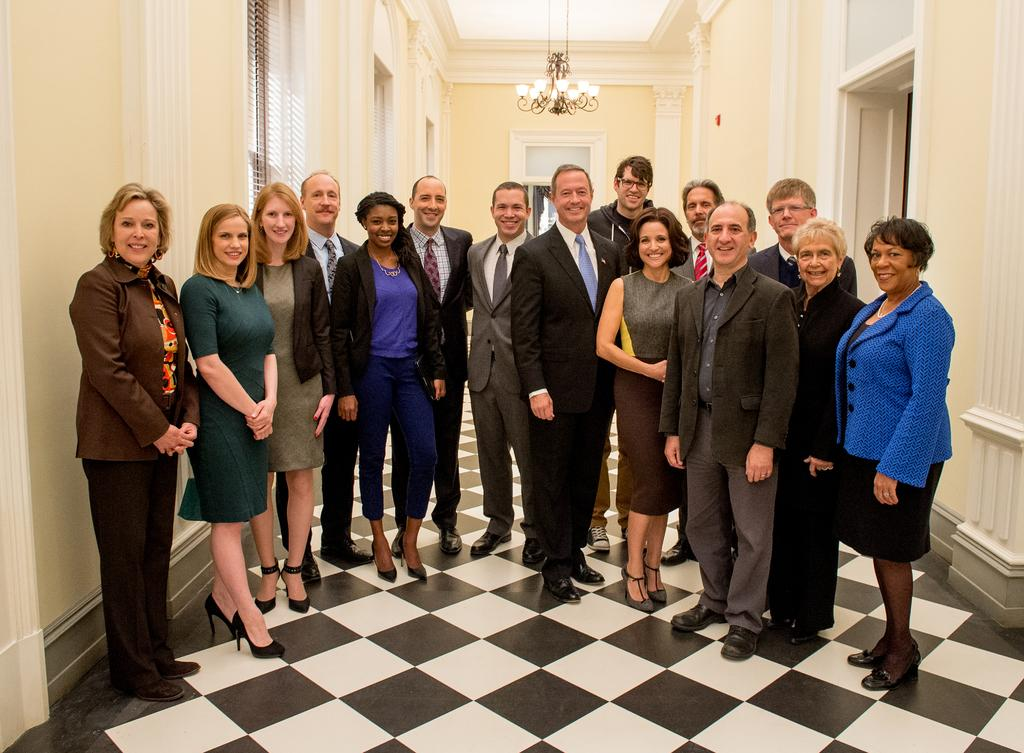How many people are in the image? There is a group of people in the image. What are the people doing in the image? The people are standing on the ground. What can be seen in the background of the image? There is a wall in the background of the image. What type of bear can be seen interacting with the people in the image? There is no bear present in the image; it only features a group of people standing on the ground with a wall in the background. 